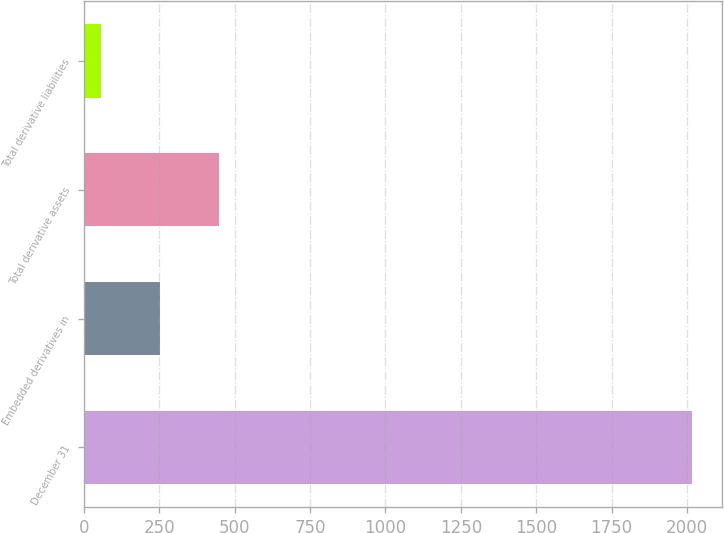Convert chart to OTSL. <chart><loc_0><loc_0><loc_500><loc_500><bar_chart><fcel>December 31<fcel>Embedded derivatives in<fcel>Total derivative assets<fcel>Total derivative liabilities<nl><fcel>2017<fcel>253<fcel>449<fcel>57<nl></chart> 